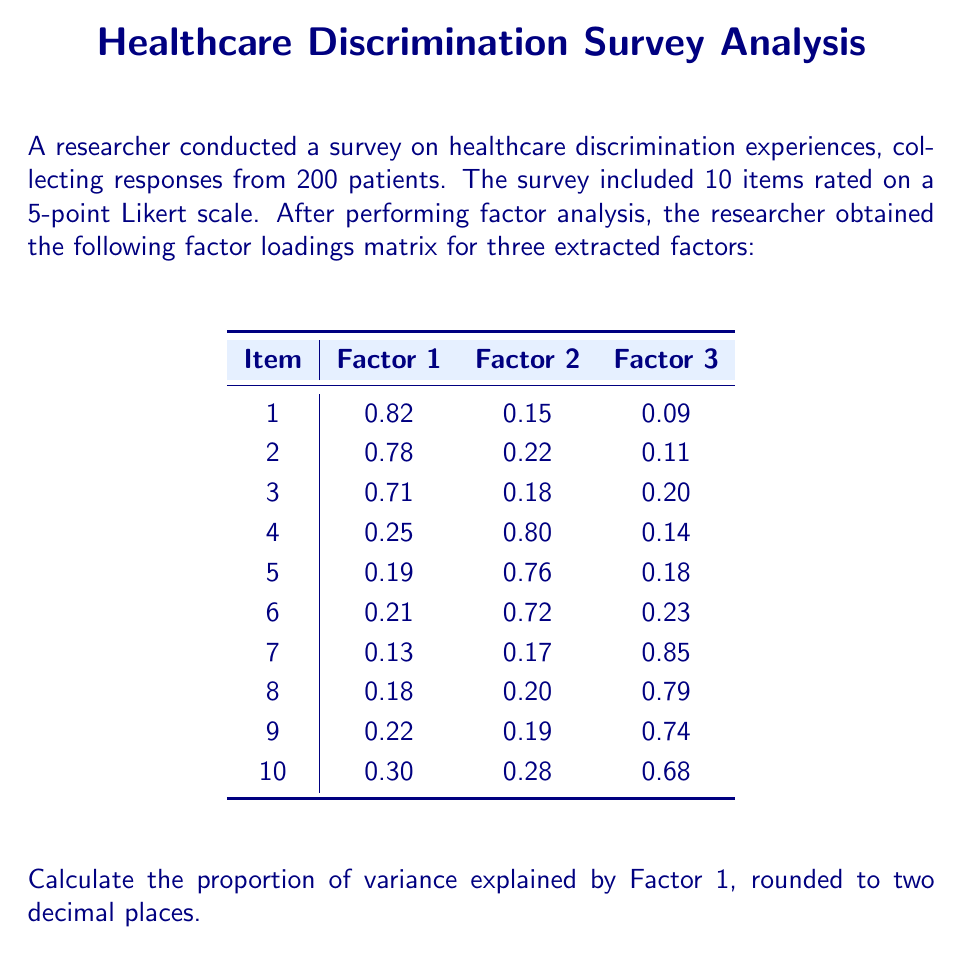Give your solution to this math problem. To calculate the proportion of variance explained by Factor 1, we need to follow these steps:

1) First, we need to square each factor loading for Factor 1. This gives us:

   $0.82^2 = 0.6724$
   $0.78^2 = 0.6084$
   $0.71^2 = 0.5041$
   $0.25^2 = 0.0625$
   $0.19^2 = 0.0361$
   $0.21^2 = 0.0441$
   $0.13^2 = 0.0169$
   $0.18^2 = 0.0324$
   $0.22^2 = 0.0484$
   $0.30^2 = 0.0900$

2) Sum these squared loadings:

   $0.6724 + 0.6084 + 0.5041 + 0.0625 + 0.0361 + 0.0441 + 0.0169 + 0.0324 + 0.0484 + 0.0900 = 2.1153$

3) Divide this sum by the number of items (10) to get the proportion of variance explained:

   $2.1153 / 10 = 0.21153$

4) Round to two decimal places:

   $0.21153 \approx 0.21$

Therefore, Factor 1 explains approximately 21% of the total variance in the survey responses.
Answer: 0.21 